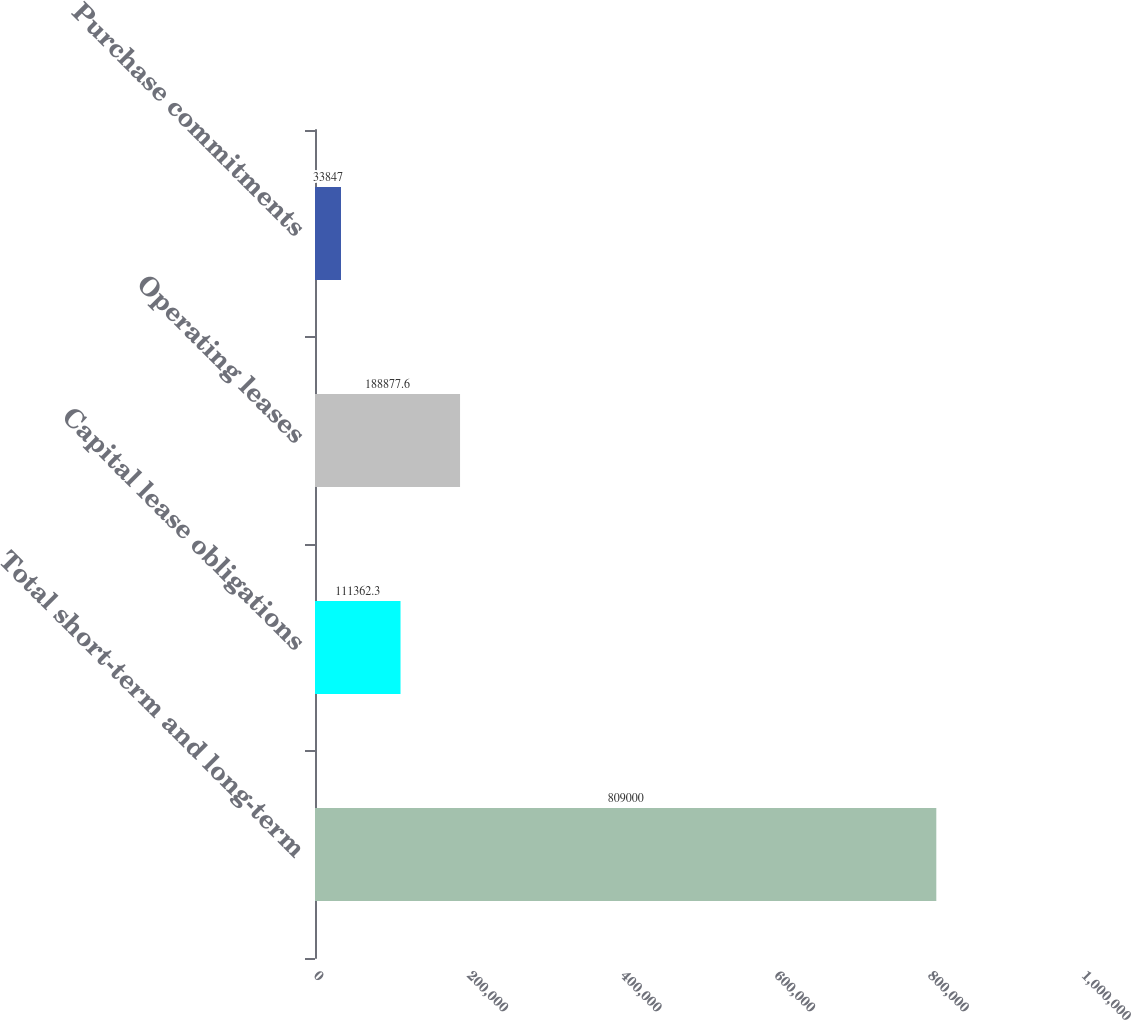Convert chart. <chart><loc_0><loc_0><loc_500><loc_500><bar_chart><fcel>Total short-term and long-term<fcel>Capital lease obligations<fcel>Operating leases<fcel>Purchase commitments<nl><fcel>809000<fcel>111362<fcel>188878<fcel>33847<nl></chart> 